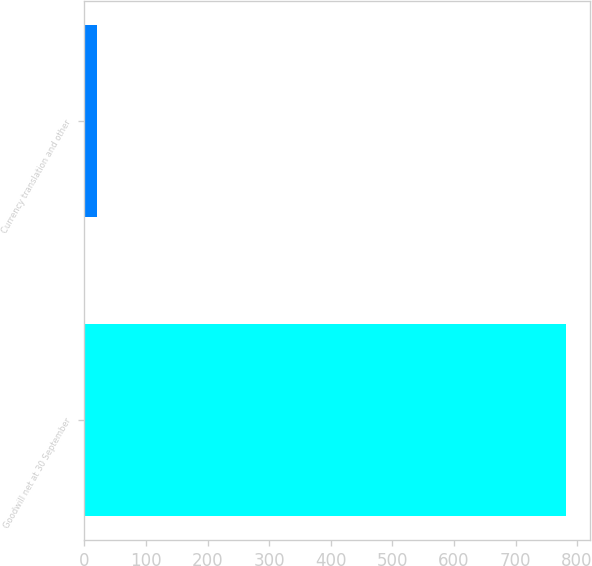Convert chart. <chart><loc_0><loc_0><loc_500><loc_500><bar_chart><fcel>Goodwill net at 30 September<fcel>Currency translation and other<nl><fcel>781.2<fcel>19.9<nl></chart> 